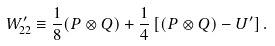Convert formula to latex. <formula><loc_0><loc_0><loc_500><loc_500>W _ { 2 2 } ^ { \prime } \equiv \frac { 1 } { 8 } ( P \otimes Q ) + \frac { 1 } { 4 } \left [ ( P \otimes Q ) - U ^ { \prime } \right ] .</formula> 